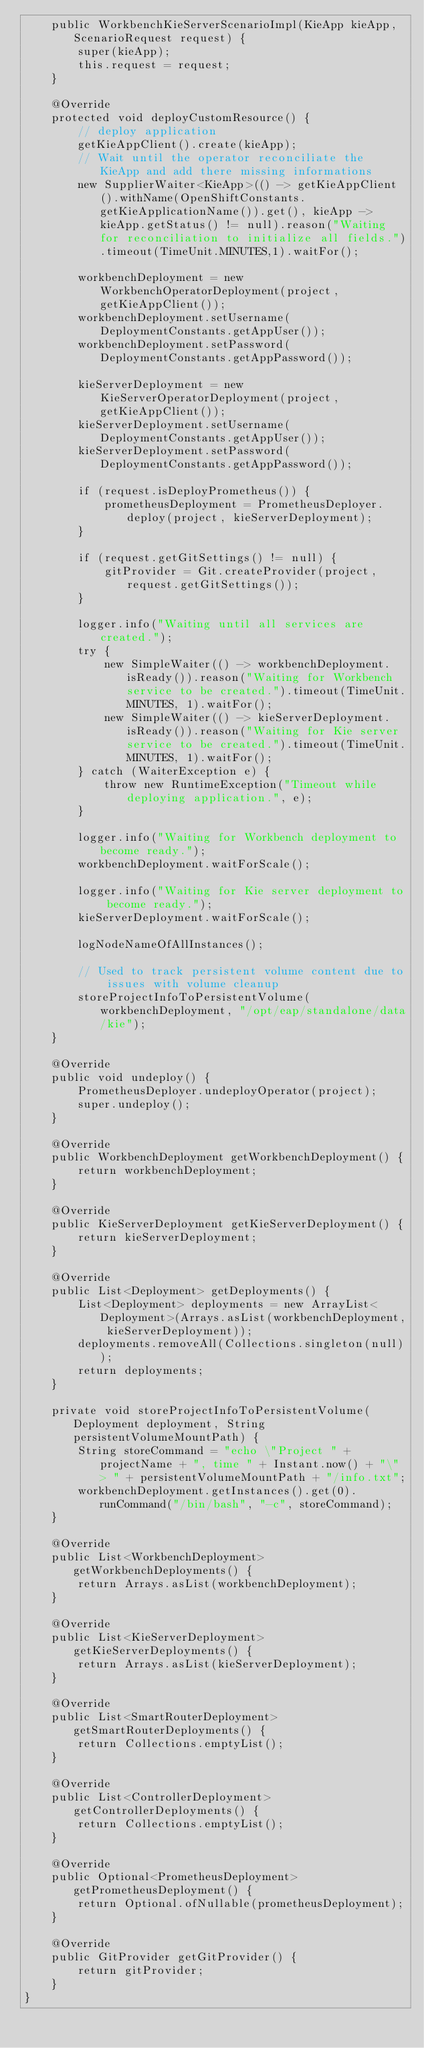Convert code to text. <code><loc_0><loc_0><loc_500><loc_500><_Java_>    public WorkbenchKieServerScenarioImpl(KieApp kieApp, ScenarioRequest request) {
        super(kieApp);
        this.request = request;
    }

    @Override
    protected void deployCustomResource() {
        // deploy application
        getKieAppClient().create(kieApp);
        // Wait until the operator reconciliate the KieApp and add there missing informations
        new SupplierWaiter<KieApp>(() -> getKieAppClient().withName(OpenShiftConstants.getKieApplicationName()).get(), kieApp -> kieApp.getStatus() != null).reason("Waiting for reconciliation to initialize all fields.").timeout(TimeUnit.MINUTES,1).waitFor();

        workbenchDeployment = new WorkbenchOperatorDeployment(project, getKieAppClient());
        workbenchDeployment.setUsername(DeploymentConstants.getAppUser());
        workbenchDeployment.setPassword(DeploymentConstants.getAppPassword());

        kieServerDeployment = new KieServerOperatorDeployment(project, getKieAppClient());
        kieServerDeployment.setUsername(DeploymentConstants.getAppUser());
        kieServerDeployment.setPassword(DeploymentConstants.getAppPassword());

        if (request.isDeployPrometheus()) {
            prometheusDeployment = PrometheusDeployer.deploy(project, kieServerDeployment);
        }

        if (request.getGitSettings() != null) {
            gitProvider = Git.createProvider(project, request.getGitSettings());
        }

        logger.info("Waiting until all services are created.");
        try {
            new SimpleWaiter(() -> workbenchDeployment.isReady()).reason("Waiting for Workbench service to be created.").timeout(TimeUnit.MINUTES, 1).waitFor();
            new SimpleWaiter(() -> kieServerDeployment.isReady()).reason("Waiting for Kie server service to be created.").timeout(TimeUnit.MINUTES, 1).waitFor();
        } catch (WaiterException e) {
            throw new RuntimeException("Timeout while deploying application.", e);
        }

        logger.info("Waiting for Workbench deployment to become ready.");
        workbenchDeployment.waitForScale();

        logger.info("Waiting for Kie server deployment to become ready.");
        kieServerDeployment.waitForScale();

        logNodeNameOfAllInstances();

        // Used to track persistent volume content due to issues with volume cleanup
        storeProjectInfoToPersistentVolume(workbenchDeployment, "/opt/eap/standalone/data/kie");
    }

    @Override
    public void undeploy() {
        PrometheusDeployer.undeployOperator(project);
        super.undeploy();
    }

    @Override
    public WorkbenchDeployment getWorkbenchDeployment() {
        return workbenchDeployment;
    }

    @Override
    public KieServerDeployment getKieServerDeployment() {
        return kieServerDeployment;
    }

    @Override
    public List<Deployment> getDeployments() {
        List<Deployment> deployments = new ArrayList<Deployment>(Arrays.asList(workbenchDeployment, kieServerDeployment));
        deployments.removeAll(Collections.singleton(null));
        return deployments;
    }

    private void storeProjectInfoToPersistentVolume(Deployment deployment, String persistentVolumeMountPath) {
        String storeCommand = "echo \"Project " + projectName + ", time " + Instant.now() + "\" > " + persistentVolumeMountPath + "/info.txt";
        workbenchDeployment.getInstances().get(0).runCommand("/bin/bash", "-c", storeCommand);
    }

    @Override
    public List<WorkbenchDeployment> getWorkbenchDeployments() {
        return Arrays.asList(workbenchDeployment);
    }

    @Override
    public List<KieServerDeployment> getKieServerDeployments() {
        return Arrays.asList(kieServerDeployment);
    }

    @Override
    public List<SmartRouterDeployment> getSmartRouterDeployments() {
        return Collections.emptyList();
    }

    @Override
    public List<ControllerDeployment> getControllerDeployments() {
        return Collections.emptyList();
    }

    @Override
    public Optional<PrometheusDeployment> getPrometheusDeployment() {
        return Optional.ofNullable(prometheusDeployment);
    }

    @Override
    public GitProvider getGitProvider() {
        return gitProvider;
    }
}
</code> 